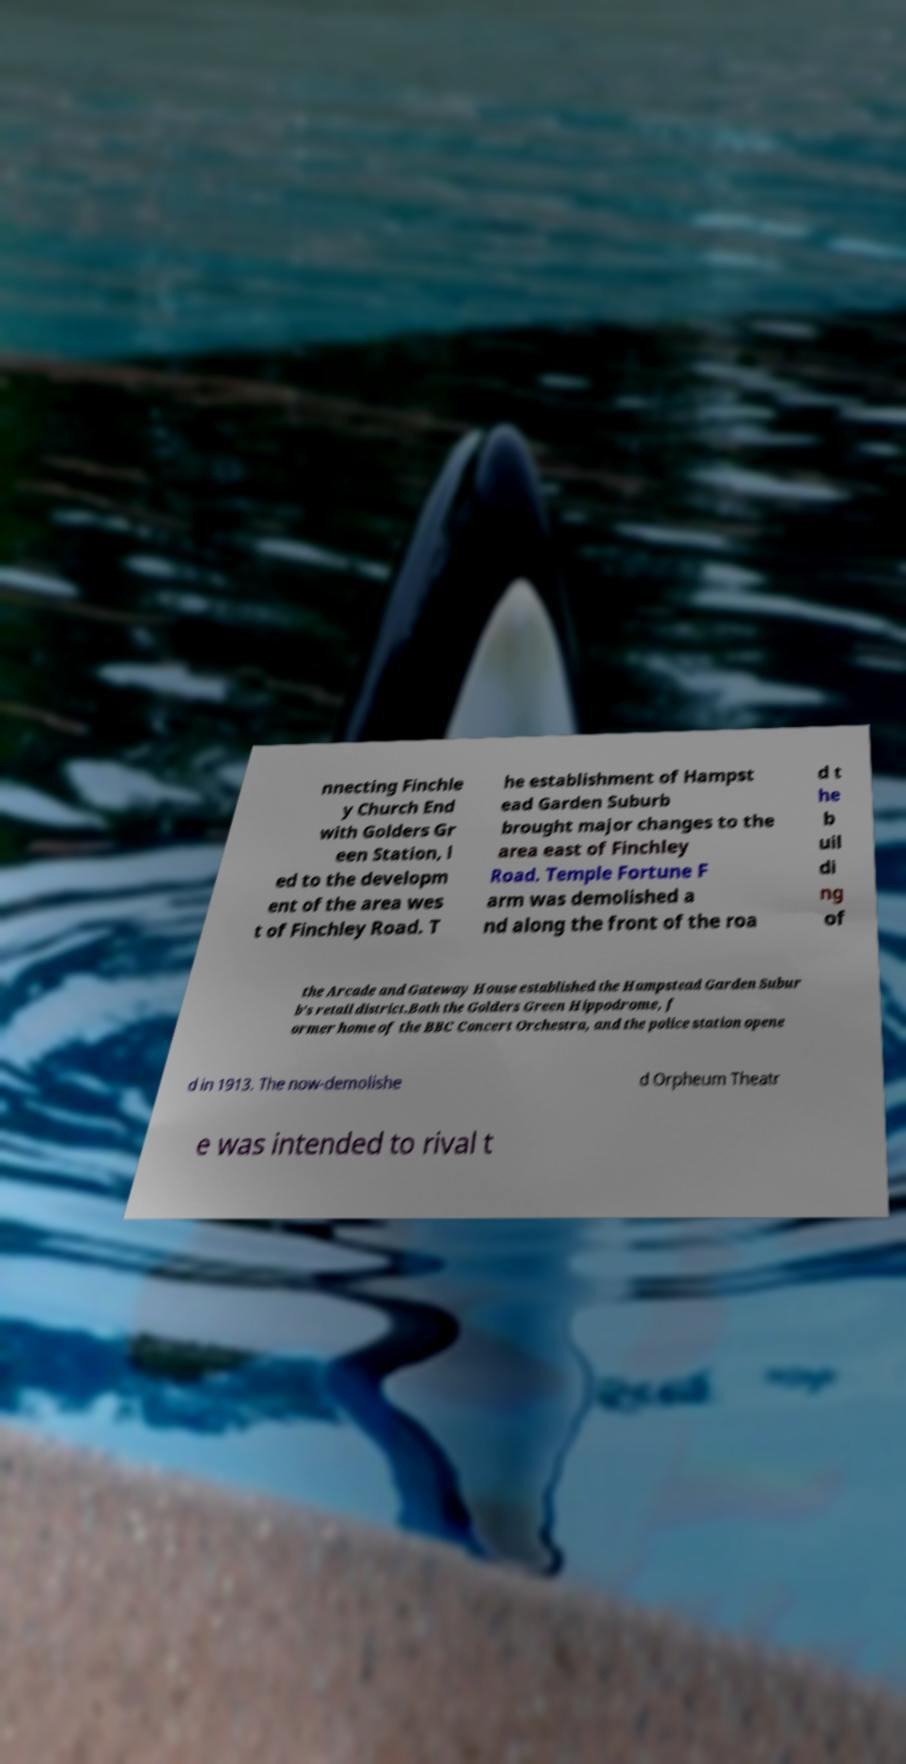Could you assist in decoding the text presented in this image and type it out clearly? nnecting Finchle y Church End with Golders Gr een Station, l ed to the developm ent of the area wes t of Finchley Road. T he establishment of Hampst ead Garden Suburb brought major changes to the area east of Finchley Road. Temple Fortune F arm was demolished a nd along the front of the roa d t he b uil di ng of the Arcade and Gateway House established the Hampstead Garden Subur b's retail district.Both the Golders Green Hippodrome, f ormer home of the BBC Concert Orchestra, and the police station opene d in 1913. The now-demolishe d Orpheum Theatr e was intended to rival t 